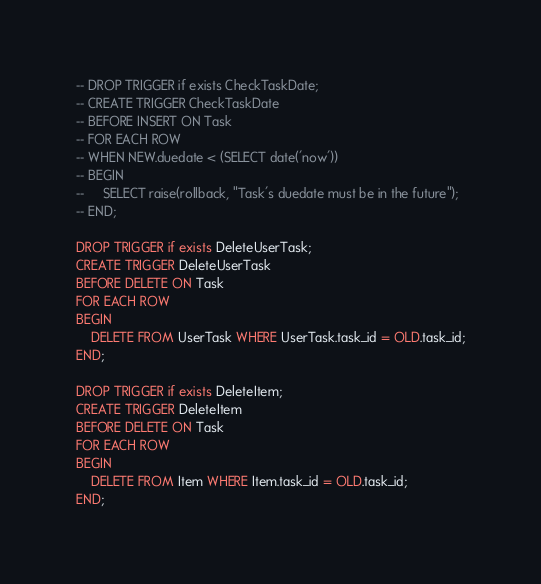<code> <loc_0><loc_0><loc_500><loc_500><_SQL_>-- DROP TRIGGER if exists CheckTaskDate;
-- CREATE TRIGGER CheckTaskDate
-- BEFORE INSERT ON Task
-- FOR EACH ROW
-- WHEN NEW.duedate < (SELECT date('now'))
-- BEGIN
--     SELECT raise(rollback, "Task's duedate must be in the future");
-- END;

DROP TRIGGER if exists DeleteUserTask;
CREATE TRIGGER DeleteUserTask
BEFORE DELETE ON Task
FOR EACH ROW
BEGIN
    DELETE FROM UserTask WHERE UserTask.task_id = OLD.task_id;
END;

DROP TRIGGER if exists DeleteItem;
CREATE TRIGGER DeleteItem
BEFORE DELETE ON Task
FOR EACH ROW
BEGIN
    DELETE FROM Item WHERE Item.task_id = OLD.task_id;
END;
</code> 